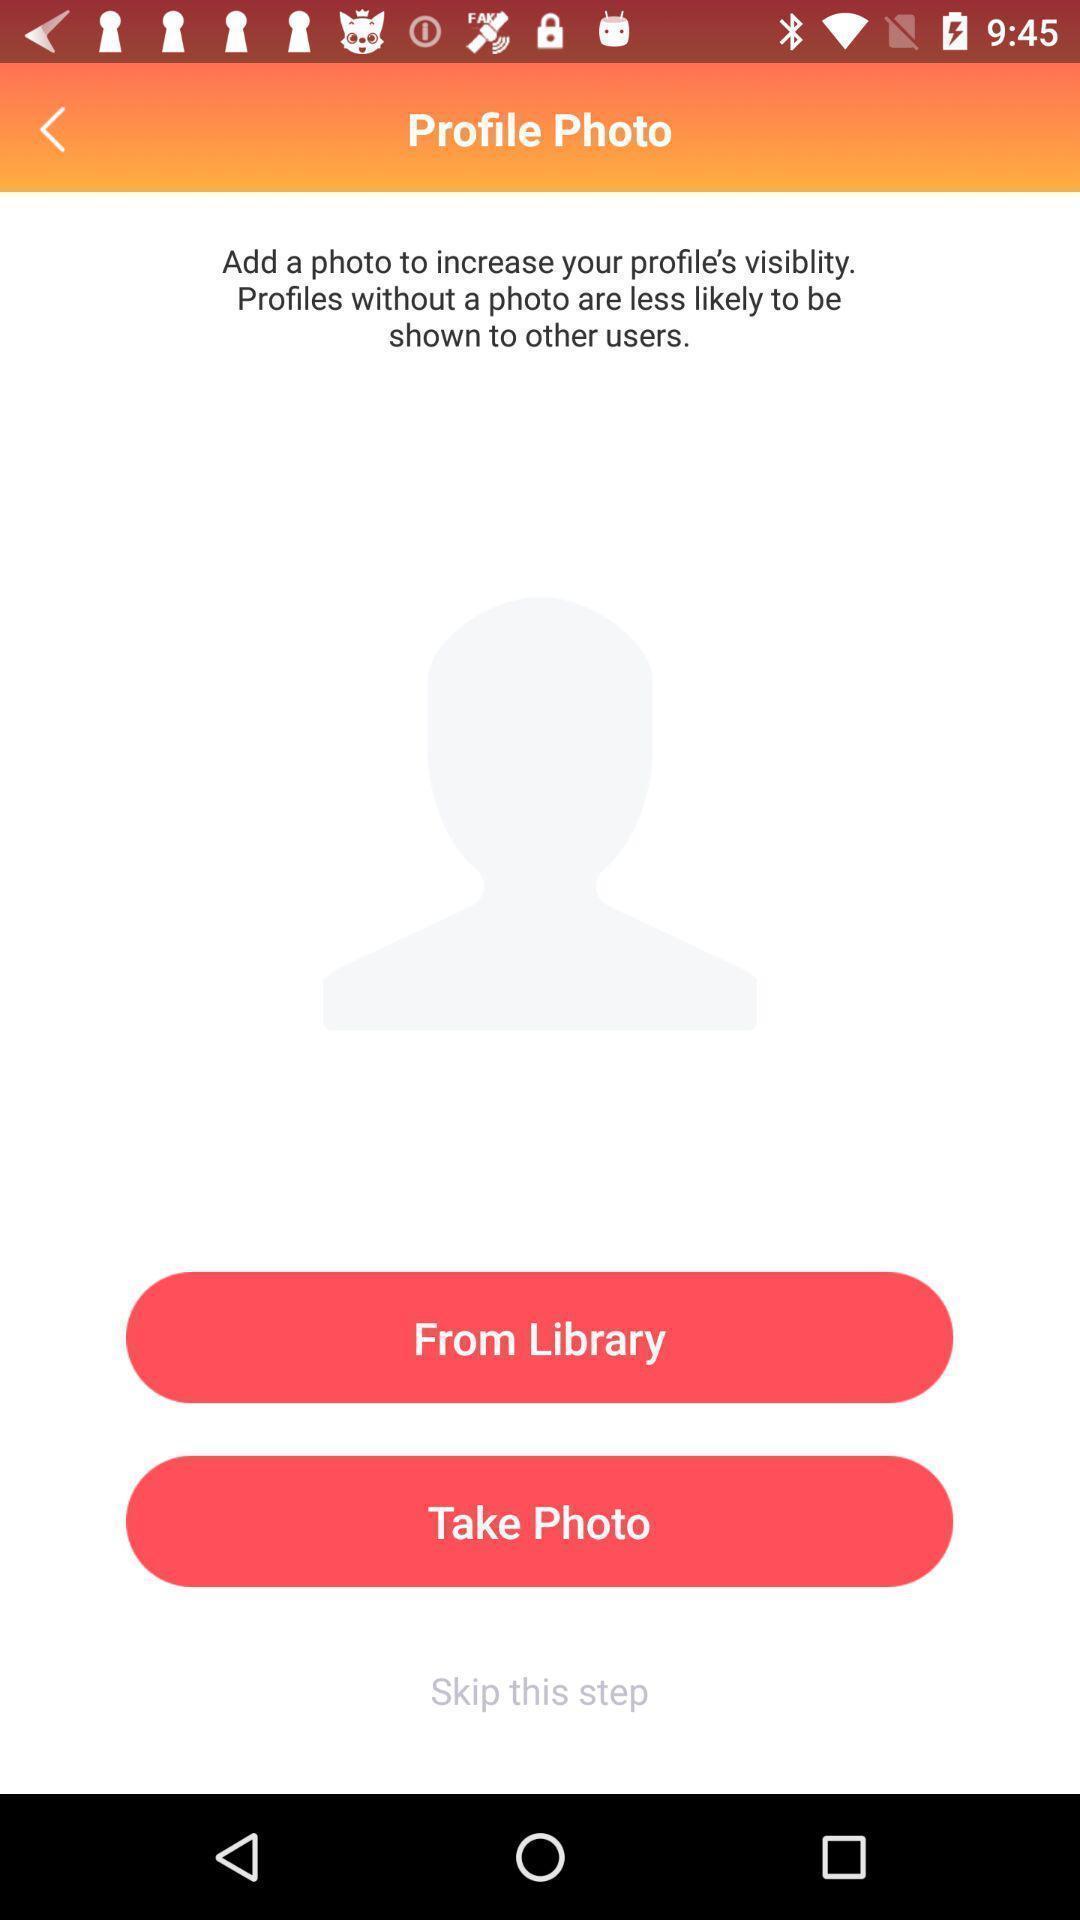Describe the content in this image. Page to select a photo from multiple options. 